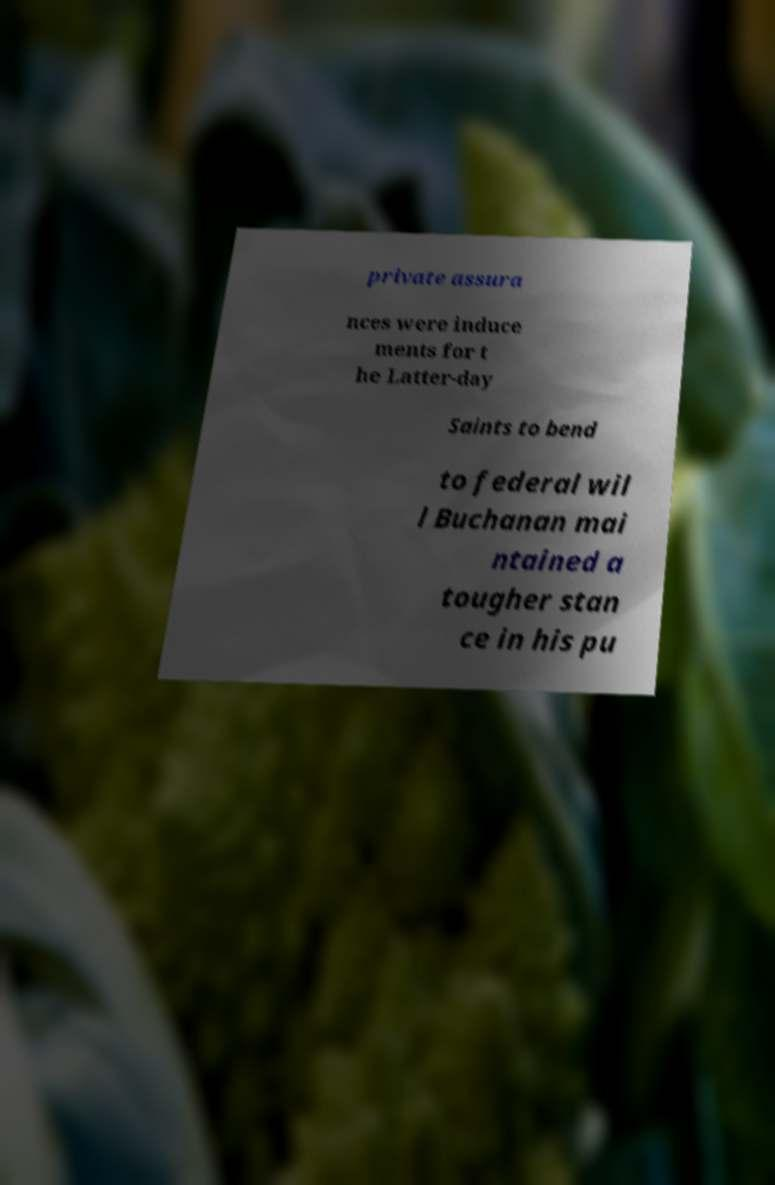Please identify and transcribe the text found in this image. private assura nces were induce ments for t he Latter-day Saints to bend to federal wil l Buchanan mai ntained a tougher stan ce in his pu 